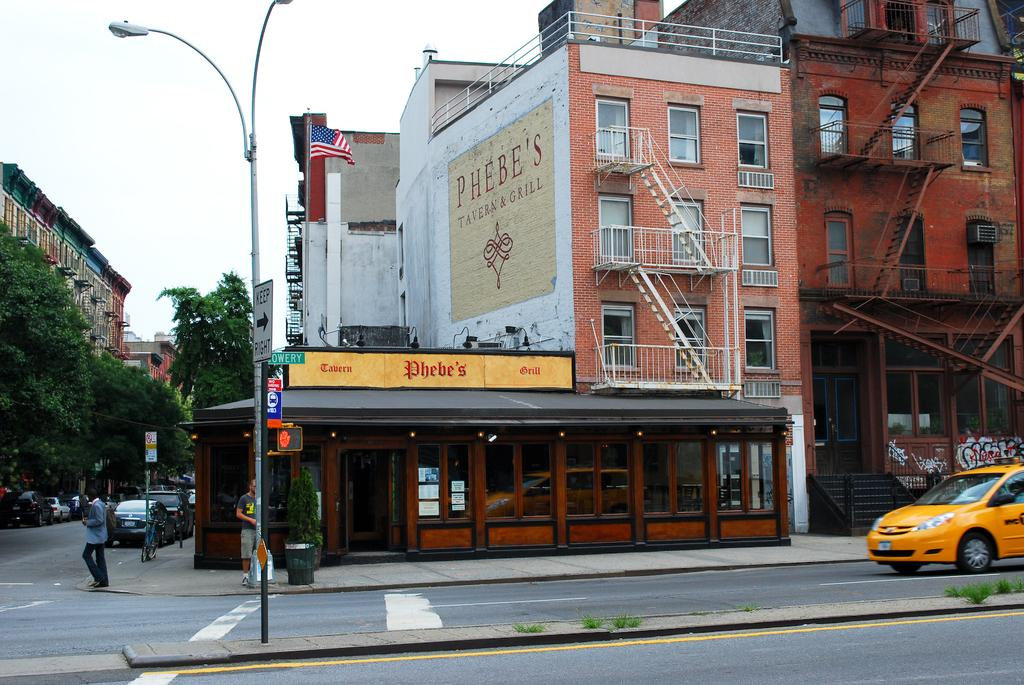<image>
Render a clear and concise summary of the photo. An intersection shows a painted building that says Phebe's Tavern & Grill. 